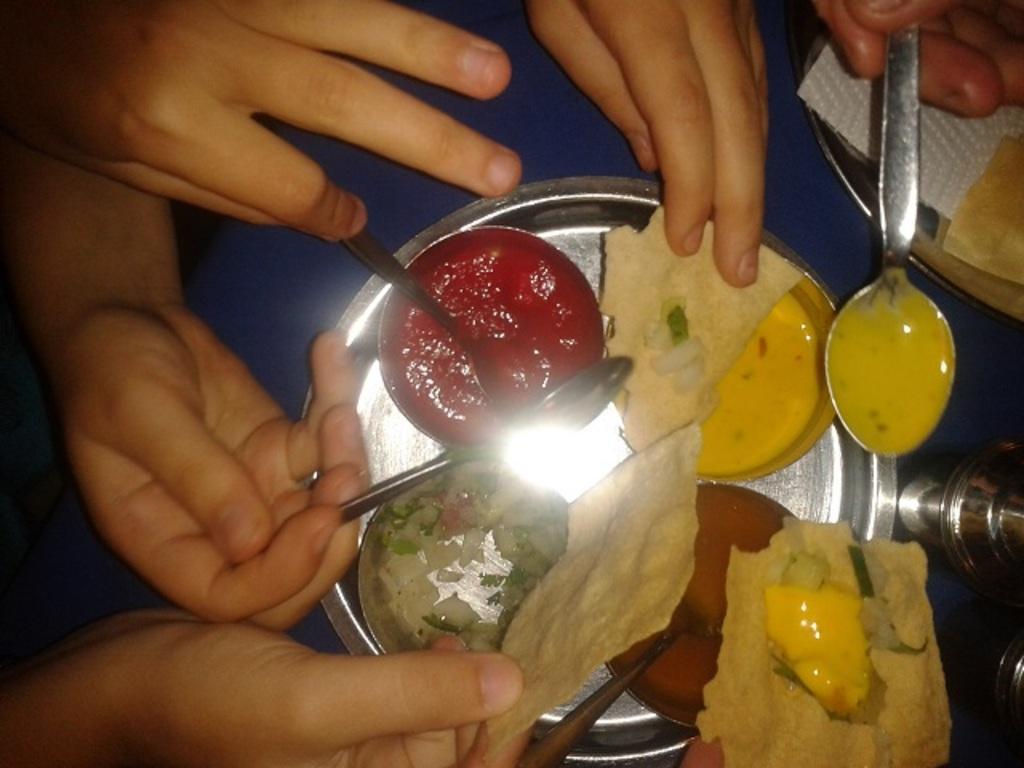Could you give a brief overview of what you see in this image? In this picture we can see the person's hand who is holding spoon and food items. On the table we can see the tissue paper, steel plates, cucumber pieces and other food items. 